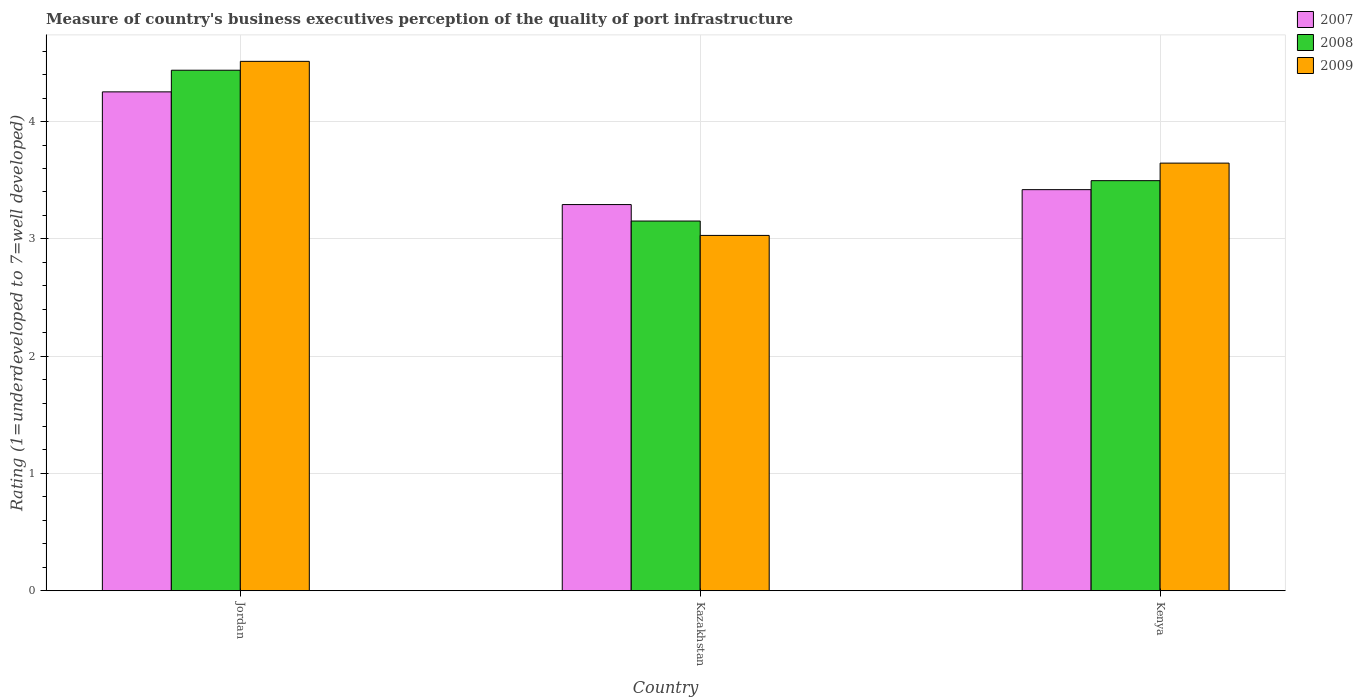How many bars are there on the 2nd tick from the left?
Give a very brief answer. 3. How many bars are there on the 1st tick from the right?
Provide a short and direct response. 3. What is the label of the 2nd group of bars from the left?
Provide a succinct answer. Kazakhstan. What is the ratings of the quality of port infrastructure in 2008 in Kenya?
Provide a short and direct response. 3.5. Across all countries, what is the maximum ratings of the quality of port infrastructure in 2009?
Keep it short and to the point. 4.51. Across all countries, what is the minimum ratings of the quality of port infrastructure in 2008?
Provide a short and direct response. 3.15. In which country was the ratings of the quality of port infrastructure in 2008 maximum?
Your answer should be very brief. Jordan. In which country was the ratings of the quality of port infrastructure in 2009 minimum?
Make the answer very short. Kazakhstan. What is the total ratings of the quality of port infrastructure in 2009 in the graph?
Offer a terse response. 11.19. What is the difference between the ratings of the quality of port infrastructure in 2007 in Kazakhstan and that in Kenya?
Your answer should be compact. -0.13. What is the difference between the ratings of the quality of port infrastructure in 2007 in Jordan and the ratings of the quality of port infrastructure in 2009 in Kenya?
Keep it short and to the point. 0.61. What is the average ratings of the quality of port infrastructure in 2009 per country?
Offer a very short reply. 3.73. What is the difference between the ratings of the quality of port infrastructure of/in 2009 and ratings of the quality of port infrastructure of/in 2008 in Jordan?
Provide a succinct answer. 0.08. In how many countries, is the ratings of the quality of port infrastructure in 2009 greater than 1.4?
Offer a terse response. 3. What is the ratio of the ratings of the quality of port infrastructure in 2007 in Jordan to that in Kazakhstan?
Provide a succinct answer. 1.29. What is the difference between the highest and the second highest ratings of the quality of port infrastructure in 2008?
Make the answer very short. -0.34. What is the difference between the highest and the lowest ratings of the quality of port infrastructure in 2008?
Provide a short and direct response. 1.29. In how many countries, is the ratings of the quality of port infrastructure in 2009 greater than the average ratings of the quality of port infrastructure in 2009 taken over all countries?
Keep it short and to the point. 1. What does the 1st bar from the left in Kenya represents?
Make the answer very short. 2007. Is it the case that in every country, the sum of the ratings of the quality of port infrastructure in 2009 and ratings of the quality of port infrastructure in 2008 is greater than the ratings of the quality of port infrastructure in 2007?
Make the answer very short. Yes. How many bars are there?
Keep it short and to the point. 9. Are all the bars in the graph horizontal?
Offer a very short reply. No. How many countries are there in the graph?
Give a very brief answer. 3. What is the difference between two consecutive major ticks on the Y-axis?
Provide a succinct answer. 1. Are the values on the major ticks of Y-axis written in scientific E-notation?
Your answer should be compact. No. Does the graph contain grids?
Offer a very short reply. Yes. How many legend labels are there?
Make the answer very short. 3. What is the title of the graph?
Offer a terse response. Measure of country's business executives perception of the quality of port infrastructure. Does "2007" appear as one of the legend labels in the graph?
Offer a terse response. Yes. What is the label or title of the X-axis?
Your response must be concise. Country. What is the label or title of the Y-axis?
Give a very brief answer. Rating (1=underdeveloped to 7=well developed). What is the Rating (1=underdeveloped to 7=well developed) of 2007 in Jordan?
Provide a short and direct response. 4.25. What is the Rating (1=underdeveloped to 7=well developed) in 2008 in Jordan?
Offer a terse response. 4.44. What is the Rating (1=underdeveloped to 7=well developed) of 2009 in Jordan?
Give a very brief answer. 4.51. What is the Rating (1=underdeveloped to 7=well developed) in 2007 in Kazakhstan?
Keep it short and to the point. 3.29. What is the Rating (1=underdeveloped to 7=well developed) in 2008 in Kazakhstan?
Give a very brief answer. 3.15. What is the Rating (1=underdeveloped to 7=well developed) of 2009 in Kazakhstan?
Your response must be concise. 3.03. What is the Rating (1=underdeveloped to 7=well developed) in 2007 in Kenya?
Ensure brevity in your answer.  3.42. What is the Rating (1=underdeveloped to 7=well developed) of 2008 in Kenya?
Your answer should be compact. 3.5. What is the Rating (1=underdeveloped to 7=well developed) in 2009 in Kenya?
Provide a succinct answer. 3.65. Across all countries, what is the maximum Rating (1=underdeveloped to 7=well developed) in 2007?
Make the answer very short. 4.25. Across all countries, what is the maximum Rating (1=underdeveloped to 7=well developed) of 2008?
Your answer should be very brief. 4.44. Across all countries, what is the maximum Rating (1=underdeveloped to 7=well developed) in 2009?
Provide a succinct answer. 4.51. Across all countries, what is the minimum Rating (1=underdeveloped to 7=well developed) in 2007?
Keep it short and to the point. 3.29. Across all countries, what is the minimum Rating (1=underdeveloped to 7=well developed) of 2008?
Make the answer very short. 3.15. Across all countries, what is the minimum Rating (1=underdeveloped to 7=well developed) of 2009?
Your answer should be compact. 3.03. What is the total Rating (1=underdeveloped to 7=well developed) of 2007 in the graph?
Provide a succinct answer. 10.97. What is the total Rating (1=underdeveloped to 7=well developed) of 2008 in the graph?
Ensure brevity in your answer.  11.09. What is the total Rating (1=underdeveloped to 7=well developed) in 2009 in the graph?
Make the answer very short. 11.19. What is the difference between the Rating (1=underdeveloped to 7=well developed) of 2007 in Jordan and that in Kazakhstan?
Give a very brief answer. 0.96. What is the difference between the Rating (1=underdeveloped to 7=well developed) of 2008 in Jordan and that in Kazakhstan?
Offer a terse response. 1.29. What is the difference between the Rating (1=underdeveloped to 7=well developed) in 2009 in Jordan and that in Kazakhstan?
Give a very brief answer. 1.48. What is the difference between the Rating (1=underdeveloped to 7=well developed) of 2007 in Jordan and that in Kenya?
Provide a succinct answer. 0.83. What is the difference between the Rating (1=underdeveloped to 7=well developed) in 2008 in Jordan and that in Kenya?
Offer a very short reply. 0.94. What is the difference between the Rating (1=underdeveloped to 7=well developed) in 2009 in Jordan and that in Kenya?
Offer a very short reply. 0.87. What is the difference between the Rating (1=underdeveloped to 7=well developed) in 2007 in Kazakhstan and that in Kenya?
Offer a terse response. -0.13. What is the difference between the Rating (1=underdeveloped to 7=well developed) in 2008 in Kazakhstan and that in Kenya?
Ensure brevity in your answer.  -0.34. What is the difference between the Rating (1=underdeveloped to 7=well developed) of 2009 in Kazakhstan and that in Kenya?
Make the answer very short. -0.62. What is the difference between the Rating (1=underdeveloped to 7=well developed) in 2007 in Jordan and the Rating (1=underdeveloped to 7=well developed) in 2008 in Kazakhstan?
Provide a succinct answer. 1.1. What is the difference between the Rating (1=underdeveloped to 7=well developed) in 2007 in Jordan and the Rating (1=underdeveloped to 7=well developed) in 2009 in Kazakhstan?
Your response must be concise. 1.22. What is the difference between the Rating (1=underdeveloped to 7=well developed) in 2008 in Jordan and the Rating (1=underdeveloped to 7=well developed) in 2009 in Kazakhstan?
Keep it short and to the point. 1.41. What is the difference between the Rating (1=underdeveloped to 7=well developed) of 2007 in Jordan and the Rating (1=underdeveloped to 7=well developed) of 2008 in Kenya?
Offer a terse response. 0.76. What is the difference between the Rating (1=underdeveloped to 7=well developed) in 2007 in Jordan and the Rating (1=underdeveloped to 7=well developed) in 2009 in Kenya?
Make the answer very short. 0.61. What is the difference between the Rating (1=underdeveloped to 7=well developed) in 2008 in Jordan and the Rating (1=underdeveloped to 7=well developed) in 2009 in Kenya?
Provide a short and direct response. 0.79. What is the difference between the Rating (1=underdeveloped to 7=well developed) of 2007 in Kazakhstan and the Rating (1=underdeveloped to 7=well developed) of 2008 in Kenya?
Make the answer very short. -0.2. What is the difference between the Rating (1=underdeveloped to 7=well developed) of 2007 in Kazakhstan and the Rating (1=underdeveloped to 7=well developed) of 2009 in Kenya?
Offer a terse response. -0.35. What is the difference between the Rating (1=underdeveloped to 7=well developed) of 2008 in Kazakhstan and the Rating (1=underdeveloped to 7=well developed) of 2009 in Kenya?
Ensure brevity in your answer.  -0.49. What is the average Rating (1=underdeveloped to 7=well developed) of 2007 per country?
Provide a short and direct response. 3.66. What is the average Rating (1=underdeveloped to 7=well developed) of 2008 per country?
Provide a short and direct response. 3.7. What is the average Rating (1=underdeveloped to 7=well developed) in 2009 per country?
Your answer should be compact. 3.73. What is the difference between the Rating (1=underdeveloped to 7=well developed) in 2007 and Rating (1=underdeveloped to 7=well developed) in 2008 in Jordan?
Provide a short and direct response. -0.18. What is the difference between the Rating (1=underdeveloped to 7=well developed) of 2007 and Rating (1=underdeveloped to 7=well developed) of 2009 in Jordan?
Give a very brief answer. -0.26. What is the difference between the Rating (1=underdeveloped to 7=well developed) in 2008 and Rating (1=underdeveloped to 7=well developed) in 2009 in Jordan?
Give a very brief answer. -0.08. What is the difference between the Rating (1=underdeveloped to 7=well developed) of 2007 and Rating (1=underdeveloped to 7=well developed) of 2008 in Kazakhstan?
Ensure brevity in your answer.  0.14. What is the difference between the Rating (1=underdeveloped to 7=well developed) in 2007 and Rating (1=underdeveloped to 7=well developed) in 2009 in Kazakhstan?
Your answer should be very brief. 0.26. What is the difference between the Rating (1=underdeveloped to 7=well developed) of 2008 and Rating (1=underdeveloped to 7=well developed) of 2009 in Kazakhstan?
Your response must be concise. 0.12. What is the difference between the Rating (1=underdeveloped to 7=well developed) of 2007 and Rating (1=underdeveloped to 7=well developed) of 2008 in Kenya?
Offer a very short reply. -0.08. What is the difference between the Rating (1=underdeveloped to 7=well developed) of 2007 and Rating (1=underdeveloped to 7=well developed) of 2009 in Kenya?
Your response must be concise. -0.23. What is the difference between the Rating (1=underdeveloped to 7=well developed) in 2008 and Rating (1=underdeveloped to 7=well developed) in 2009 in Kenya?
Make the answer very short. -0.15. What is the ratio of the Rating (1=underdeveloped to 7=well developed) of 2007 in Jordan to that in Kazakhstan?
Offer a terse response. 1.29. What is the ratio of the Rating (1=underdeveloped to 7=well developed) of 2008 in Jordan to that in Kazakhstan?
Provide a succinct answer. 1.41. What is the ratio of the Rating (1=underdeveloped to 7=well developed) in 2009 in Jordan to that in Kazakhstan?
Your answer should be compact. 1.49. What is the ratio of the Rating (1=underdeveloped to 7=well developed) of 2007 in Jordan to that in Kenya?
Provide a short and direct response. 1.24. What is the ratio of the Rating (1=underdeveloped to 7=well developed) in 2008 in Jordan to that in Kenya?
Keep it short and to the point. 1.27. What is the ratio of the Rating (1=underdeveloped to 7=well developed) of 2009 in Jordan to that in Kenya?
Your response must be concise. 1.24. What is the ratio of the Rating (1=underdeveloped to 7=well developed) of 2007 in Kazakhstan to that in Kenya?
Provide a short and direct response. 0.96. What is the ratio of the Rating (1=underdeveloped to 7=well developed) of 2008 in Kazakhstan to that in Kenya?
Give a very brief answer. 0.9. What is the ratio of the Rating (1=underdeveloped to 7=well developed) of 2009 in Kazakhstan to that in Kenya?
Ensure brevity in your answer.  0.83. What is the difference between the highest and the second highest Rating (1=underdeveloped to 7=well developed) in 2007?
Your answer should be very brief. 0.83. What is the difference between the highest and the second highest Rating (1=underdeveloped to 7=well developed) in 2008?
Provide a succinct answer. 0.94. What is the difference between the highest and the second highest Rating (1=underdeveloped to 7=well developed) in 2009?
Offer a terse response. 0.87. What is the difference between the highest and the lowest Rating (1=underdeveloped to 7=well developed) of 2007?
Your answer should be very brief. 0.96. What is the difference between the highest and the lowest Rating (1=underdeveloped to 7=well developed) in 2008?
Make the answer very short. 1.29. What is the difference between the highest and the lowest Rating (1=underdeveloped to 7=well developed) in 2009?
Provide a succinct answer. 1.48. 